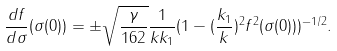<formula> <loc_0><loc_0><loc_500><loc_500>\frac { d f } { d \sigma } ( \sigma ( 0 ) ) = \pm \sqrt { \frac { \gamma } { 1 6 2 } } \frac { 1 } { k k _ { 1 } } ( 1 - ( \frac { k _ { 1 } } { k } ) ^ { 2 } f ^ { 2 } ( \sigma ( 0 ) ) ) ^ { - 1 / 2 } .</formula> 